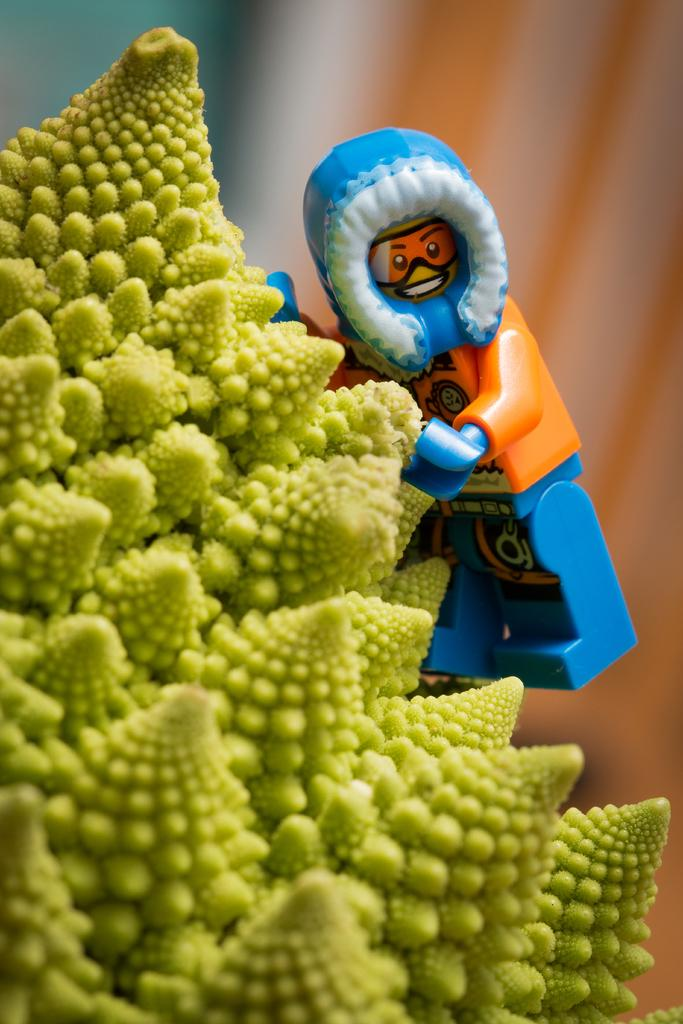What type of green vegetable is present in the image? There is a green vegetable in the image. What is placed on the green vegetable? There is a toy on the green vegetable. Can you describe the background of the image? The background of the image is blurred. What type of quartz can be seen covering the green vegetable in the image? There is no quartz present in the image, nor is it covering the green vegetable. 